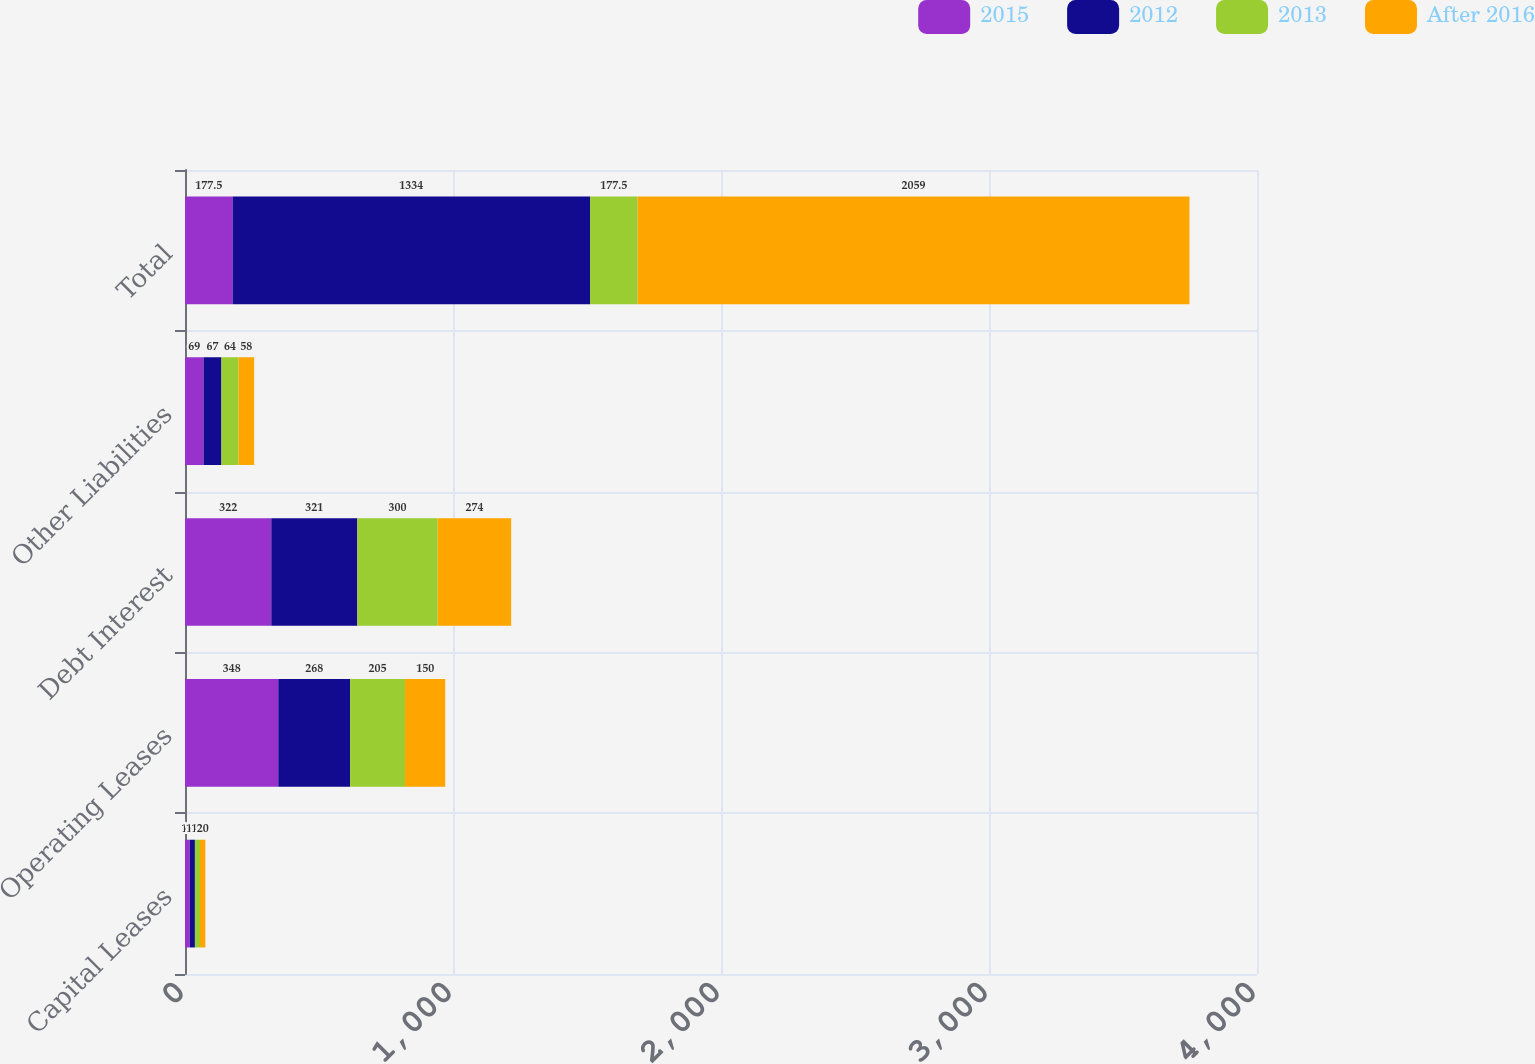<chart> <loc_0><loc_0><loc_500><loc_500><stacked_bar_chart><ecel><fcel>Capital Leases<fcel>Operating Leases<fcel>Debt Interest<fcel>Other Liabilities<fcel>Total<nl><fcel>2015<fcel>18<fcel>348<fcel>322<fcel>69<fcel>177.5<nl><fcel>2012<fcel>19<fcel>268<fcel>321<fcel>67<fcel>1334<nl><fcel>2013<fcel>19<fcel>205<fcel>300<fcel>64<fcel>177.5<nl><fcel>After 2016<fcel>20<fcel>150<fcel>274<fcel>58<fcel>2059<nl></chart> 